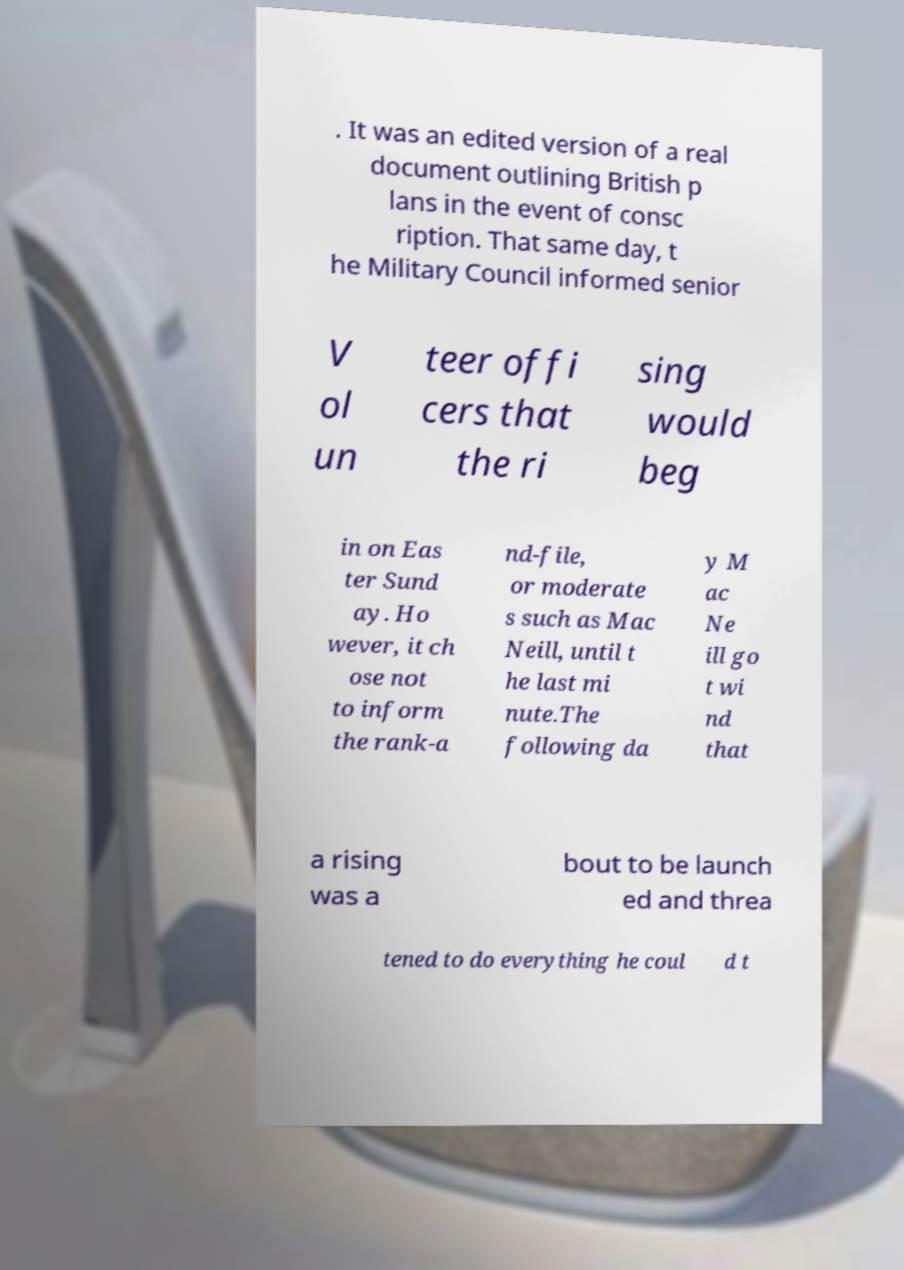Please identify and transcribe the text found in this image. . It was an edited version of a real document outlining British p lans in the event of consc ription. That same day, t he Military Council informed senior V ol un teer offi cers that the ri sing would beg in on Eas ter Sund ay. Ho wever, it ch ose not to inform the rank-a nd-file, or moderate s such as Mac Neill, until t he last mi nute.The following da y M ac Ne ill go t wi nd that a rising was a bout to be launch ed and threa tened to do everything he coul d t 